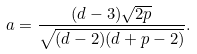Convert formula to latex. <formula><loc_0><loc_0><loc_500><loc_500>a = \frac { ( d - 3 ) \sqrt { 2 p } } { \sqrt { ( d - 2 ) ( d + p - 2 ) } } .</formula> 